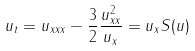Convert formula to latex. <formula><loc_0><loc_0><loc_500><loc_500>u _ { t } = u _ { x x x } - \frac { 3 } { 2 } \frac { u _ { x x } ^ { 2 } } { u _ { x } } = u _ { x } S ( u )</formula> 